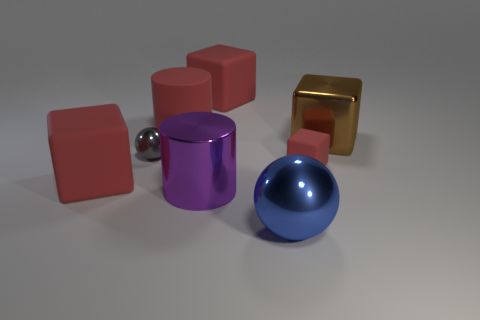The tiny object that is to the right of the ball that is in front of the big matte cube in front of the small matte block is what color?
Your answer should be compact. Red. Is the size of the blue metal sphere the same as the red block that is behind the tiny gray sphere?
Keep it short and to the point. Yes. What number of things are either spheres on the right side of the red rubber cylinder or red matte blocks behind the shiny cube?
Provide a succinct answer. 2. The purple shiny thing that is the same size as the blue metallic thing is what shape?
Your response must be concise. Cylinder. What is the shape of the small gray object that is on the right side of the large red matte block in front of the big matte object to the right of the purple thing?
Ensure brevity in your answer.  Sphere. Are there an equal number of balls to the left of the red cylinder and brown cubes?
Provide a succinct answer. Yes. Does the blue metallic sphere have the same size as the brown thing?
Provide a succinct answer. Yes. How many matte objects are either blocks or tiny yellow spheres?
Keep it short and to the point. 3. There is a brown object that is the same size as the metallic cylinder; what is its material?
Offer a terse response. Metal. How many other things are made of the same material as the red cylinder?
Give a very brief answer. 3. 